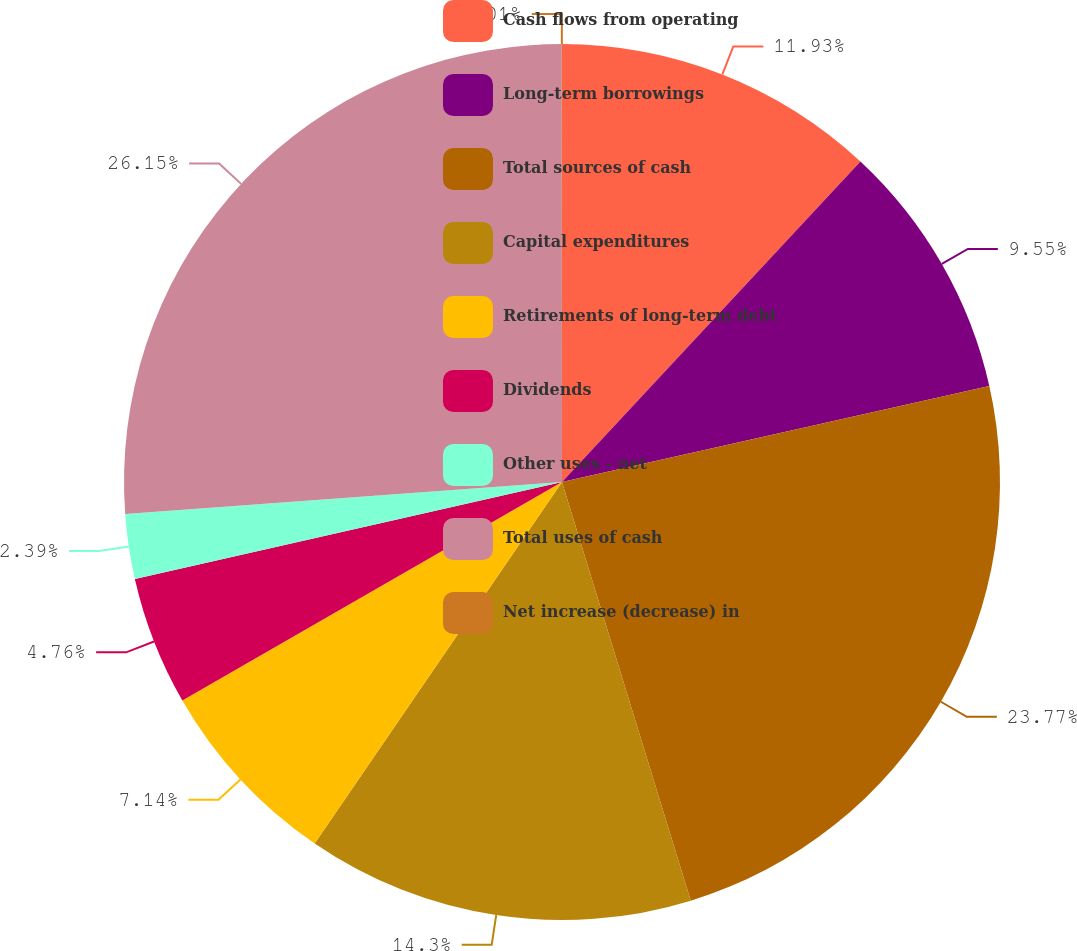Convert chart to OTSL. <chart><loc_0><loc_0><loc_500><loc_500><pie_chart><fcel>Cash flows from operating<fcel>Long-term borrowings<fcel>Total sources of cash<fcel>Capital expenditures<fcel>Retirements of long-term debt<fcel>Dividends<fcel>Other uses - net<fcel>Total uses of cash<fcel>Net increase (decrease) in<nl><fcel>11.93%<fcel>9.55%<fcel>23.77%<fcel>14.3%<fcel>7.14%<fcel>4.76%<fcel>2.39%<fcel>26.15%<fcel>0.01%<nl></chart> 